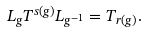<formula> <loc_0><loc_0><loc_500><loc_500>L _ { g } T ^ { s ( g ) } L _ { g ^ { - 1 } } = T _ { r ( g ) } .</formula> 